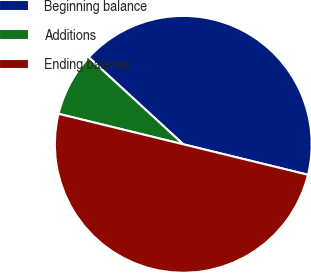Convert chart. <chart><loc_0><loc_0><loc_500><loc_500><pie_chart><fcel>Beginning balance<fcel>Additions<fcel>Ending balance<nl><fcel>41.98%<fcel>8.02%<fcel>50.0%<nl></chart> 